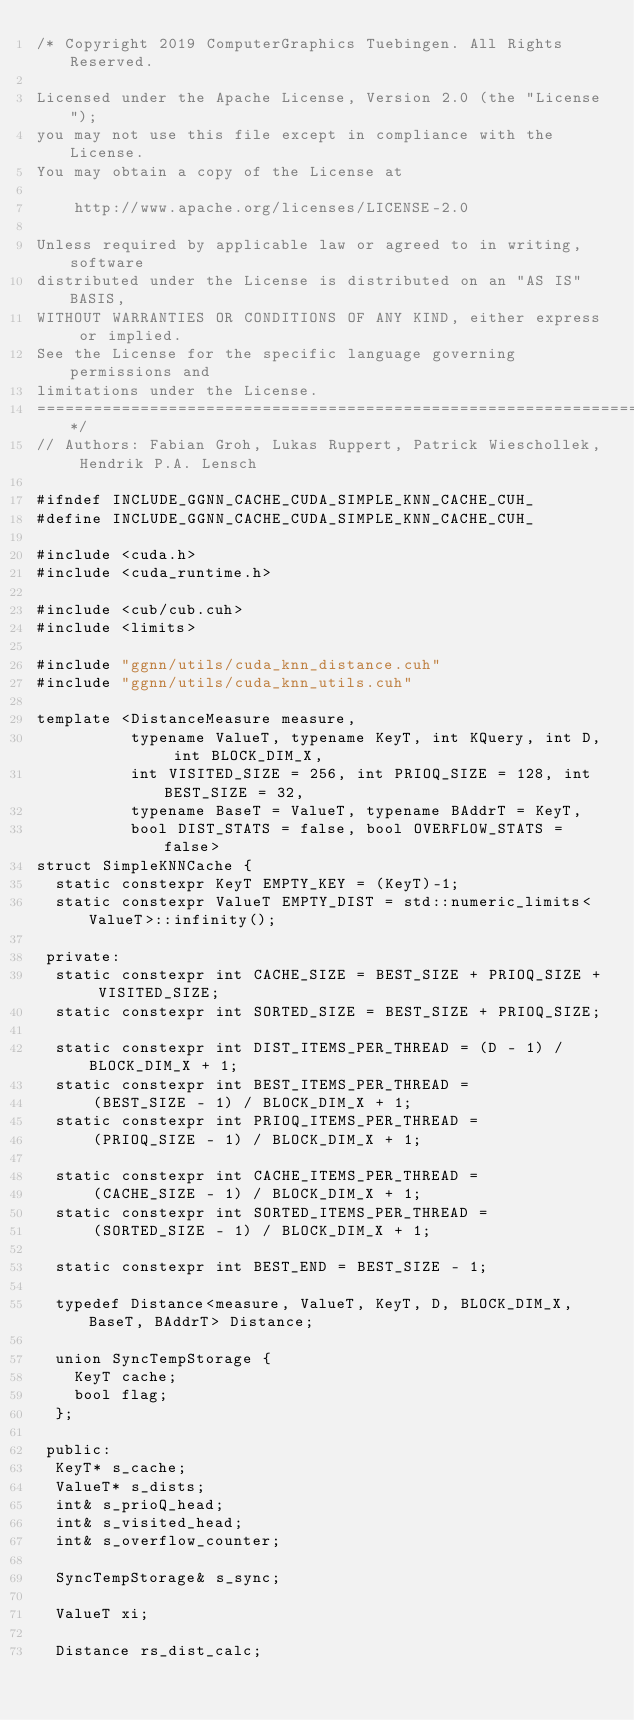<code> <loc_0><loc_0><loc_500><loc_500><_Cuda_>/* Copyright 2019 ComputerGraphics Tuebingen. All Rights Reserved.

Licensed under the Apache License, Version 2.0 (the "License");
you may not use this file except in compliance with the License.
You may obtain a copy of the License at

    http://www.apache.org/licenses/LICENSE-2.0

Unless required by applicable law or agreed to in writing, software
distributed under the License is distributed on an "AS IS" BASIS,
WITHOUT WARRANTIES OR CONDITIONS OF ANY KIND, either express or implied.
See the License for the specific language governing permissions and
limitations under the License.
==============================================================================*/
// Authors: Fabian Groh, Lukas Ruppert, Patrick Wieschollek, Hendrik P.A. Lensch

#ifndef INCLUDE_GGNN_CACHE_CUDA_SIMPLE_KNN_CACHE_CUH_
#define INCLUDE_GGNN_CACHE_CUDA_SIMPLE_KNN_CACHE_CUH_

#include <cuda.h>
#include <cuda_runtime.h>

#include <cub/cub.cuh>
#include <limits>

#include "ggnn/utils/cuda_knn_distance.cuh"
#include "ggnn/utils/cuda_knn_utils.cuh"

template <DistanceMeasure measure,
          typename ValueT, typename KeyT, int KQuery, int D, int BLOCK_DIM_X,
          int VISITED_SIZE = 256, int PRIOQ_SIZE = 128, int BEST_SIZE = 32,
          typename BaseT = ValueT, typename BAddrT = KeyT,
          bool DIST_STATS = false, bool OVERFLOW_STATS = false>
struct SimpleKNNCache {
  static constexpr KeyT EMPTY_KEY = (KeyT)-1;
  static constexpr ValueT EMPTY_DIST = std::numeric_limits<ValueT>::infinity();

 private:
  static constexpr int CACHE_SIZE = BEST_SIZE + PRIOQ_SIZE + VISITED_SIZE;
  static constexpr int SORTED_SIZE = BEST_SIZE + PRIOQ_SIZE;

  static constexpr int DIST_ITEMS_PER_THREAD = (D - 1) / BLOCK_DIM_X + 1;
  static constexpr int BEST_ITEMS_PER_THREAD =
      (BEST_SIZE - 1) / BLOCK_DIM_X + 1;
  static constexpr int PRIOQ_ITEMS_PER_THREAD =
      (PRIOQ_SIZE - 1) / BLOCK_DIM_X + 1;

  static constexpr int CACHE_ITEMS_PER_THREAD =
      (CACHE_SIZE - 1) / BLOCK_DIM_X + 1;
  static constexpr int SORTED_ITEMS_PER_THREAD =
      (SORTED_SIZE - 1) / BLOCK_DIM_X + 1;

  static constexpr int BEST_END = BEST_SIZE - 1;

  typedef Distance<measure, ValueT, KeyT, D, BLOCK_DIM_X, BaseT, BAddrT> Distance;

  union SyncTempStorage {
    KeyT cache;
    bool flag;
  };

 public:
  KeyT* s_cache;
  ValueT* s_dists;
  int& s_prioQ_head;
  int& s_visited_head;
  int& s_overflow_counter;

  SyncTempStorage& s_sync;

  ValueT xi;

  Distance rs_dist_calc;
</code> 